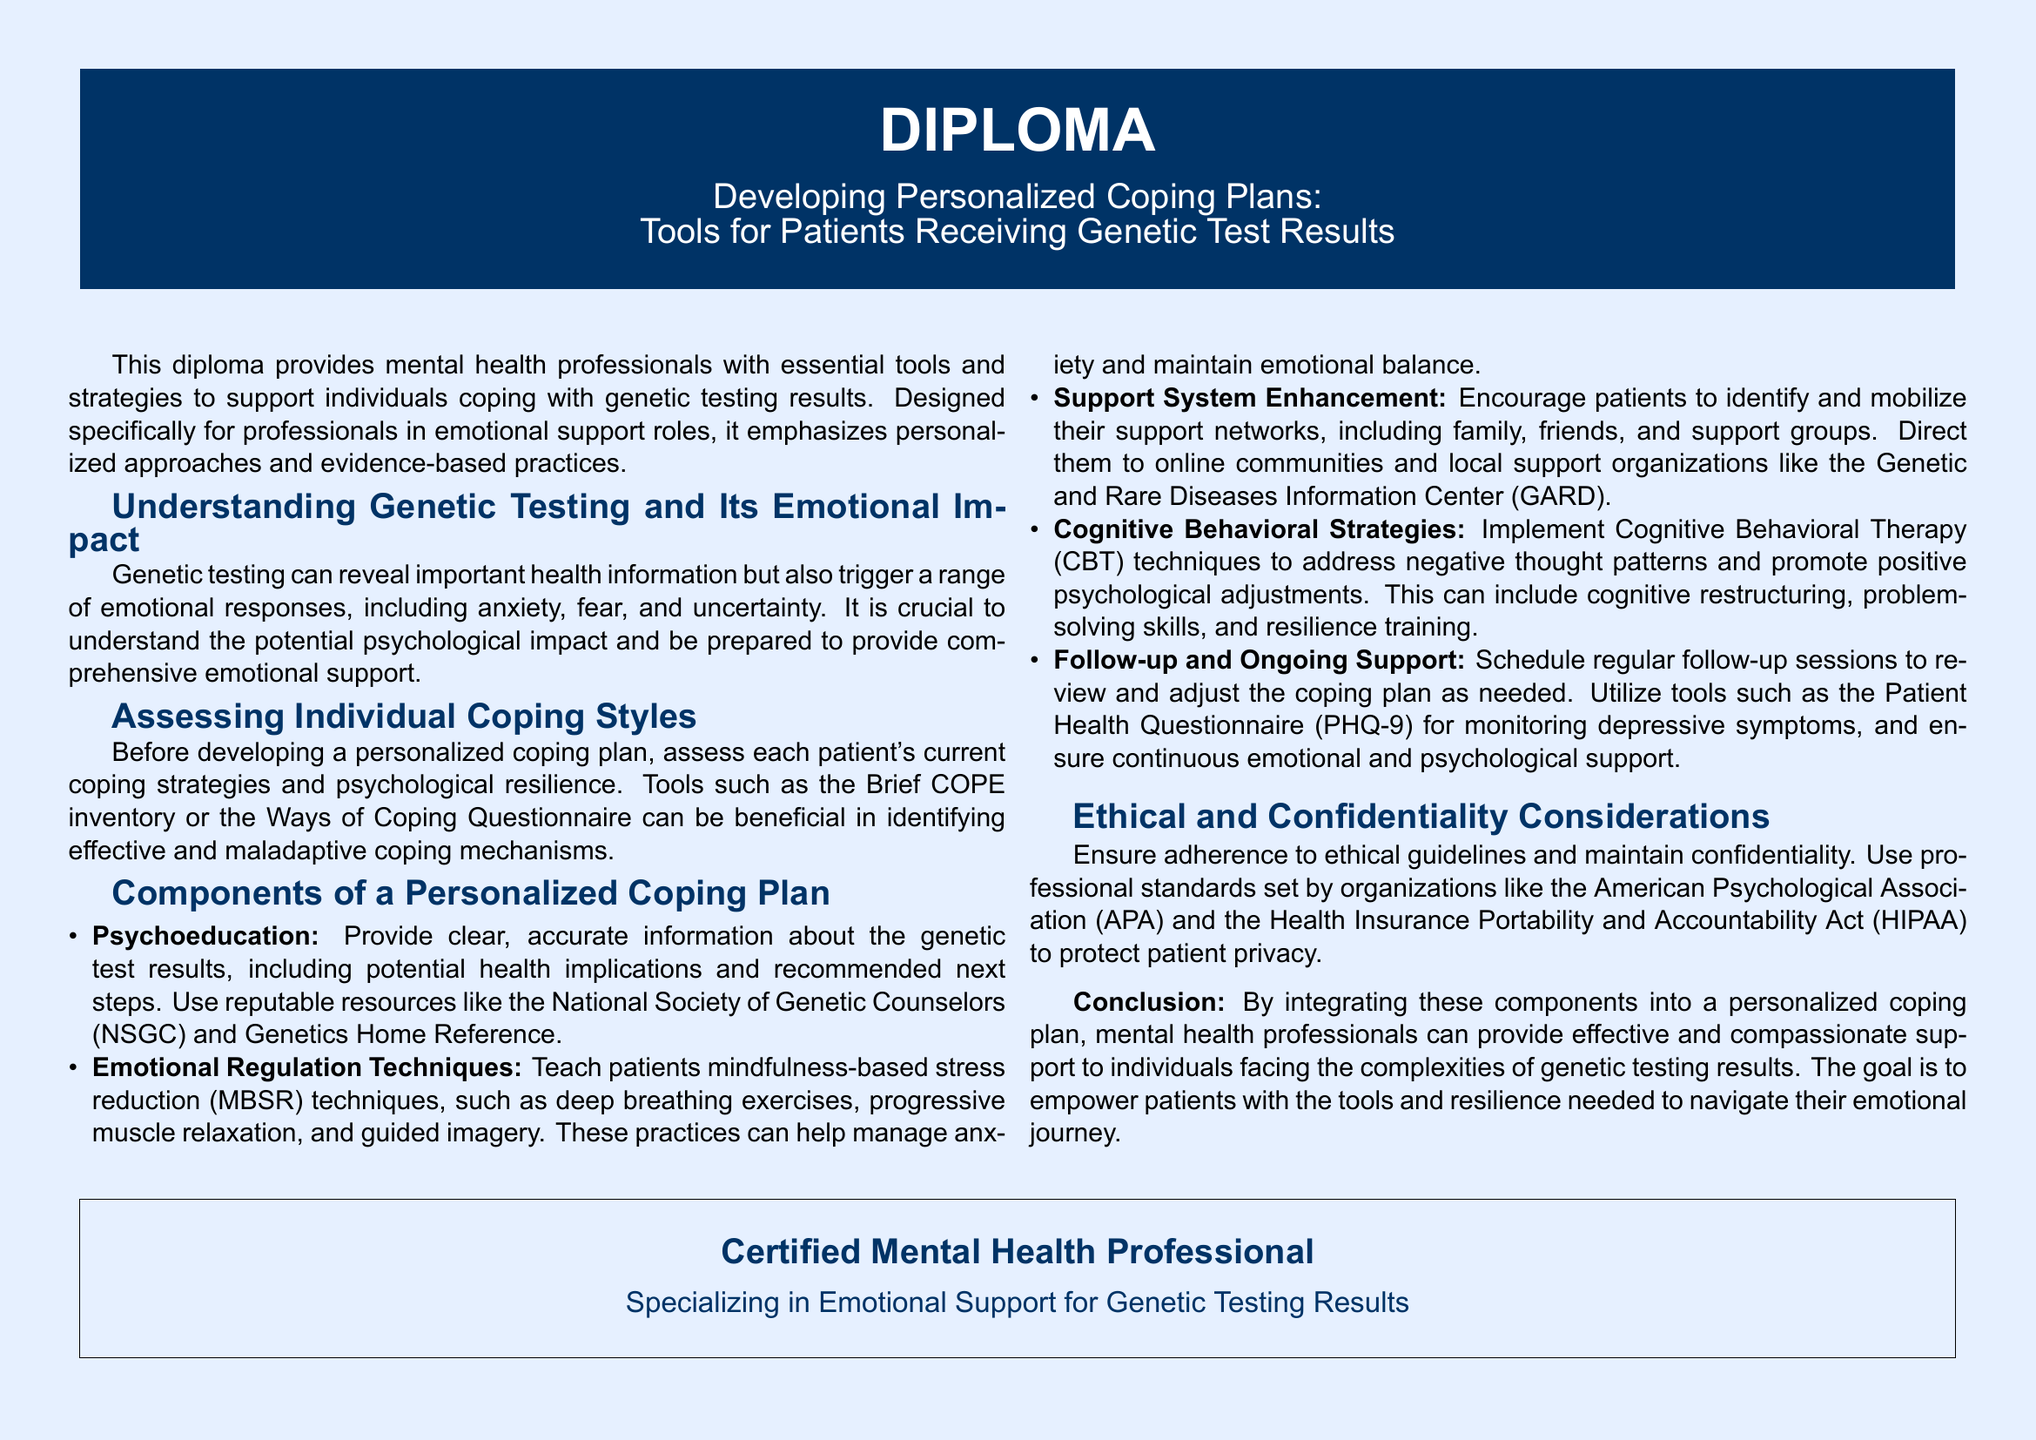What is the title of the diploma? The title is found in the header of the document and is clearly stated atop the page.
Answer: Developing Personalized Coping Plans: Tools for Patients Receiving Genetic Test Results What are the tools mentioned for assessing individual coping styles? The document lists specific tools used to assess coping styles under the relevant section.
Answer: Brief COPE inventory or the Ways of Coping Questionnaire What does the emotional regulation techniques section recommend? The diploma provides a list of specific techniques that can be taught to patients to help manage their emotional responses.
Answer: Mindfulness-based stress reduction techniques What is the purpose of follow-up and ongoing support? The document explains the significance of regular check-ins to ensure effective support.
Answer: To review and adjust the coping plan as needed Which ethical organizations are mentioned in the diploma? The diploma references specific professional organizations that set guidelines for ethical practices.
Answer: American Psychological Association (APA) and HIPAA What type of professional is targeted by this diploma? The document specifies the professional audience for which the diploma is designed.
Answer: Certified Mental Health Professional What does psychoeducation involve according to the document? The document outlines what psychoeducation should encompass when helping patients understand their genetic test results.
Answer: Clear, accurate information about the genetic test results What is the main theme of the diploma's conclusion? The conclusion summarises the goal and focus of the diploma in supporting patients emotionally.
Answer: Empower patients with tools and resilience_needed to navigate their emotional journey 